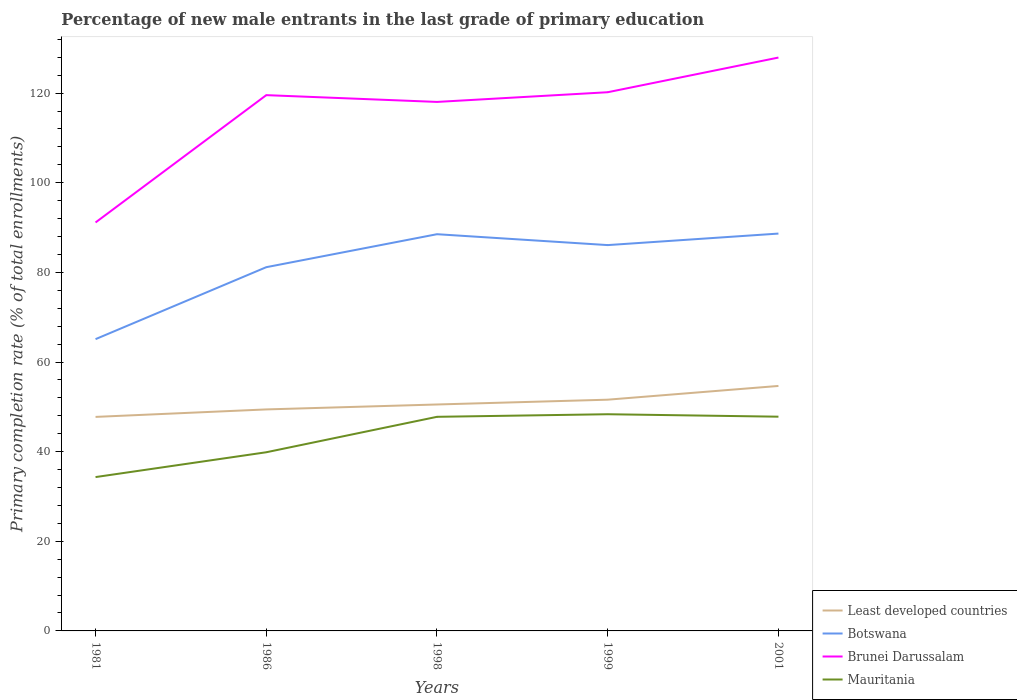Is the number of lines equal to the number of legend labels?
Give a very brief answer. Yes. Across all years, what is the maximum percentage of new male entrants in Least developed countries?
Offer a terse response. 47.75. In which year was the percentage of new male entrants in Botswana maximum?
Keep it short and to the point. 1981. What is the total percentage of new male entrants in Botswana in the graph?
Provide a succinct answer. -4.93. What is the difference between the highest and the second highest percentage of new male entrants in Mauritania?
Offer a very short reply. 14.02. What is the difference between the highest and the lowest percentage of new male entrants in Mauritania?
Give a very brief answer. 3. How many lines are there?
Keep it short and to the point. 4. What is the difference between two consecutive major ticks on the Y-axis?
Give a very brief answer. 20. Are the values on the major ticks of Y-axis written in scientific E-notation?
Give a very brief answer. No. Does the graph contain grids?
Your answer should be compact. No. Where does the legend appear in the graph?
Your response must be concise. Bottom right. How many legend labels are there?
Provide a short and direct response. 4. What is the title of the graph?
Offer a terse response. Percentage of new male entrants in the last grade of primary education. Does "Isle of Man" appear as one of the legend labels in the graph?
Give a very brief answer. No. What is the label or title of the Y-axis?
Provide a succinct answer. Primary completion rate (% of total enrollments). What is the Primary completion rate (% of total enrollments) of Least developed countries in 1981?
Your answer should be compact. 47.75. What is the Primary completion rate (% of total enrollments) in Botswana in 1981?
Keep it short and to the point. 65.1. What is the Primary completion rate (% of total enrollments) of Brunei Darussalam in 1981?
Offer a terse response. 91.14. What is the Primary completion rate (% of total enrollments) of Mauritania in 1981?
Give a very brief answer. 34.33. What is the Primary completion rate (% of total enrollments) in Least developed countries in 1986?
Offer a very short reply. 49.42. What is the Primary completion rate (% of total enrollments) in Botswana in 1986?
Provide a succinct answer. 81.16. What is the Primary completion rate (% of total enrollments) in Brunei Darussalam in 1986?
Make the answer very short. 119.54. What is the Primary completion rate (% of total enrollments) in Mauritania in 1986?
Your answer should be compact. 39.87. What is the Primary completion rate (% of total enrollments) of Least developed countries in 1998?
Offer a terse response. 50.52. What is the Primary completion rate (% of total enrollments) in Botswana in 1998?
Your answer should be very brief. 88.52. What is the Primary completion rate (% of total enrollments) of Brunei Darussalam in 1998?
Give a very brief answer. 118.03. What is the Primary completion rate (% of total enrollments) of Mauritania in 1998?
Your answer should be very brief. 47.77. What is the Primary completion rate (% of total enrollments) of Least developed countries in 1999?
Your response must be concise. 51.6. What is the Primary completion rate (% of total enrollments) in Botswana in 1999?
Give a very brief answer. 86.09. What is the Primary completion rate (% of total enrollments) in Brunei Darussalam in 1999?
Ensure brevity in your answer.  120.2. What is the Primary completion rate (% of total enrollments) of Mauritania in 1999?
Your answer should be very brief. 48.35. What is the Primary completion rate (% of total enrollments) of Least developed countries in 2001?
Give a very brief answer. 54.66. What is the Primary completion rate (% of total enrollments) in Botswana in 2001?
Keep it short and to the point. 88.66. What is the Primary completion rate (% of total enrollments) of Brunei Darussalam in 2001?
Your response must be concise. 127.93. What is the Primary completion rate (% of total enrollments) in Mauritania in 2001?
Your answer should be very brief. 47.8. Across all years, what is the maximum Primary completion rate (% of total enrollments) of Least developed countries?
Ensure brevity in your answer.  54.66. Across all years, what is the maximum Primary completion rate (% of total enrollments) in Botswana?
Offer a very short reply. 88.66. Across all years, what is the maximum Primary completion rate (% of total enrollments) in Brunei Darussalam?
Make the answer very short. 127.93. Across all years, what is the maximum Primary completion rate (% of total enrollments) in Mauritania?
Keep it short and to the point. 48.35. Across all years, what is the minimum Primary completion rate (% of total enrollments) in Least developed countries?
Your answer should be very brief. 47.75. Across all years, what is the minimum Primary completion rate (% of total enrollments) in Botswana?
Your response must be concise. 65.1. Across all years, what is the minimum Primary completion rate (% of total enrollments) in Brunei Darussalam?
Offer a terse response. 91.14. Across all years, what is the minimum Primary completion rate (% of total enrollments) in Mauritania?
Your response must be concise. 34.33. What is the total Primary completion rate (% of total enrollments) of Least developed countries in the graph?
Your response must be concise. 253.96. What is the total Primary completion rate (% of total enrollments) in Botswana in the graph?
Offer a terse response. 409.52. What is the total Primary completion rate (% of total enrollments) in Brunei Darussalam in the graph?
Provide a succinct answer. 576.84. What is the total Primary completion rate (% of total enrollments) of Mauritania in the graph?
Your answer should be compact. 218.11. What is the difference between the Primary completion rate (% of total enrollments) in Least developed countries in 1981 and that in 1986?
Ensure brevity in your answer.  -1.67. What is the difference between the Primary completion rate (% of total enrollments) in Botswana in 1981 and that in 1986?
Keep it short and to the point. -16.06. What is the difference between the Primary completion rate (% of total enrollments) in Brunei Darussalam in 1981 and that in 1986?
Give a very brief answer. -28.41. What is the difference between the Primary completion rate (% of total enrollments) in Mauritania in 1981 and that in 1986?
Offer a very short reply. -5.54. What is the difference between the Primary completion rate (% of total enrollments) of Least developed countries in 1981 and that in 1998?
Provide a succinct answer. -2.77. What is the difference between the Primary completion rate (% of total enrollments) of Botswana in 1981 and that in 1998?
Your response must be concise. -23.41. What is the difference between the Primary completion rate (% of total enrollments) in Brunei Darussalam in 1981 and that in 1998?
Your answer should be compact. -26.9. What is the difference between the Primary completion rate (% of total enrollments) of Mauritania in 1981 and that in 1998?
Offer a very short reply. -13.45. What is the difference between the Primary completion rate (% of total enrollments) in Least developed countries in 1981 and that in 1999?
Give a very brief answer. -3.84. What is the difference between the Primary completion rate (% of total enrollments) of Botswana in 1981 and that in 1999?
Provide a succinct answer. -20.99. What is the difference between the Primary completion rate (% of total enrollments) of Brunei Darussalam in 1981 and that in 1999?
Your response must be concise. -29.06. What is the difference between the Primary completion rate (% of total enrollments) in Mauritania in 1981 and that in 1999?
Offer a very short reply. -14.02. What is the difference between the Primary completion rate (% of total enrollments) in Least developed countries in 1981 and that in 2001?
Give a very brief answer. -6.91. What is the difference between the Primary completion rate (% of total enrollments) in Botswana in 1981 and that in 2001?
Give a very brief answer. -23.55. What is the difference between the Primary completion rate (% of total enrollments) in Brunei Darussalam in 1981 and that in 2001?
Provide a succinct answer. -36.8. What is the difference between the Primary completion rate (% of total enrollments) in Mauritania in 1981 and that in 2001?
Provide a succinct answer. -13.48. What is the difference between the Primary completion rate (% of total enrollments) in Least developed countries in 1986 and that in 1998?
Make the answer very short. -1.1. What is the difference between the Primary completion rate (% of total enrollments) of Botswana in 1986 and that in 1998?
Make the answer very short. -7.36. What is the difference between the Primary completion rate (% of total enrollments) in Brunei Darussalam in 1986 and that in 1998?
Offer a very short reply. 1.51. What is the difference between the Primary completion rate (% of total enrollments) in Mauritania in 1986 and that in 1998?
Provide a short and direct response. -7.91. What is the difference between the Primary completion rate (% of total enrollments) of Least developed countries in 1986 and that in 1999?
Your response must be concise. -2.17. What is the difference between the Primary completion rate (% of total enrollments) of Botswana in 1986 and that in 1999?
Keep it short and to the point. -4.93. What is the difference between the Primary completion rate (% of total enrollments) of Brunei Darussalam in 1986 and that in 1999?
Provide a succinct answer. -0.65. What is the difference between the Primary completion rate (% of total enrollments) in Mauritania in 1986 and that in 1999?
Keep it short and to the point. -8.48. What is the difference between the Primary completion rate (% of total enrollments) in Least developed countries in 1986 and that in 2001?
Your response must be concise. -5.24. What is the difference between the Primary completion rate (% of total enrollments) in Botswana in 1986 and that in 2001?
Offer a very short reply. -7.5. What is the difference between the Primary completion rate (% of total enrollments) of Brunei Darussalam in 1986 and that in 2001?
Keep it short and to the point. -8.39. What is the difference between the Primary completion rate (% of total enrollments) of Mauritania in 1986 and that in 2001?
Your response must be concise. -7.94. What is the difference between the Primary completion rate (% of total enrollments) of Least developed countries in 1998 and that in 1999?
Offer a terse response. -1.07. What is the difference between the Primary completion rate (% of total enrollments) in Botswana in 1998 and that in 1999?
Give a very brief answer. 2.43. What is the difference between the Primary completion rate (% of total enrollments) of Brunei Darussalam in 1998 and that in 1999?
Your answer should be compact. -2.16. What is the difference between the Primary completion rate (% of total enrollments) in Mauritania in 1998 and that in 1999?
Your answer should be compact. -0.58. What is the difference between the Primary completion rate (% of total enrollments) in Least developed countries in 1998 and that in 2001?
Provide a succinct answer. -4.14. What is the difference between the Primary completion rate (% of total enrollments) in Botswana in 1998 and that in 2001?
Offer a terse response. -0.14. What is the difference between the Primary completion rate (% of total enrollments) in Brunei Darussalam in 1998 and that in 2001?
Your answer should be very brief. -9.9. What is the difference between the Primary completion rate (% of total enrollments) of Mauritania in 1998 and that in 2001?
Keep it short and to the point. -0.03. What is the difference between the Primary completion rate (% of total enrollments) in Least developed countries in 1999 and that in 2001?
Your response must be concise. -3.07. What is the difference between the Primary completion rate (% of total enrollments) of Botswana in 1999 and that in 2001?
Offer a terse response. -2.57. What is the difference between the Primary completion rate (% of total enrollments) of Brunei Darussalam in 1999 and that in 2001?
Provide a short and direct response. -7.74. What is the difference between the Primary completion rate (% of total enrollments) of Mauritania in 1999 and that in 2001?
Keep it short and to the point. 0.55. What is the difference between the Primary completion rate (% of total enrollments) in Least developed countries in 1981 and the Primary completion rate (% of total enrollments) in Botswana in 1986?
Offer a very short reply. -33.4. What is the difference between the Primary completion rate (% of total enrollments) in Least developed countries in 1981 and the Primary completion rate (% of total enrollments) in Brunei Darussalam in 1986?
Keep it short and to the point. -71.79. What is the difference between the Primary completion rate (% of total enrollments) in Least developed countries in 1981 and the Primary completion rate (% of total enrollments) in Mauritania in 1986?
Give a very brief answer. 7.89. What is the difference between the Primary completion rate (% of total enrollments) in Botswana in 1981 and the Primary completion rate (% of total enrollments) in Brunei Darussalam in 1986?
Give a very brief answer. -54.44. What is the difference between the Primary completion rate (% of total enrollments) of Botswana in 1981 and the Primary completion rate (% of total enrollments) of Mauritania in 1986?
Provide a succinct answer. 25.24. What is the difference between the Primary completion rate (% of total enrollments) in Brunei Darussalam in 1981 and the Primary completion rate (% of total enrollments) in Mauritania in 1986?
Your answer should be compact. 51.27. What is the difference between the Primary completion rate (% of total enrollments) in Least developed countries in 1981 and the Primary completion rate (% of total enrollments) in Botswana in 1998?
Offer a terse response. -40.76. What is the difference between the Primary completion rate (% of total enrollments) of Least developed countries in 1981 and the Primary completion rate (% of total enrollments) of Brunei Darussalam in 1998?
Your answer should be very brief. -70.28. What is the difference between the Primary completion rate (% of total enrollments) of Least developed countries in 1981 and the Primary completion rate (% of total enrollments) of Mauritania in 1998?
Offer a terse response. -0.02. What is the difference between the Primary completion rate (% of total enrollments) of Botswana in 1981 and the Primary completion rate (% of total enrollments) of Brunei Darussalam in 1998?
Make the answer very short. -52.93. What is the difference between the Primary completion rate (% of total enrollments) in Botswana in 1981 and the Primary completion rate (% of total enrollments) in Mauritania in 1998?
Keep it short and to the point. 17.33. What is the difference between the Primary completion rate (% of total enrollments) of Brunei Darussalam in 1981 and the Primary completion rate (% of total enrollments) of Mauritania in 1998?
Keep it short and to the point. 43.36. What is the difference between the Primary completion rate (% of total enrollments) of Least developed countries in 1981 and the Primary completion rate (% of total enrollments) of Botswana in 1999?
Give a very brief answer. -38.33. What is the difference between the Primary completion rate (% of total enrollments) of Least developed countries in 1981 and the Primary completion rate (% of total enrollments) of Brunei Darussalam in 1999?
Your response must be concise. -72.44. What is the difference between the Primary completion rate (% of total enrollments) in Least developed countries in 1981 and the Primary completion rate (% of total enrollments) in Mauritania in 1999?
Provide a short and direct response. -0.59. What is the difference between the Primary completion rate (% of total enrollments) in Botswana in 1981 and the Primary completion rate (% of total enrollments) in Brunei Darussalam in 1999?
Your response must be concise. -55.09. What is the difference between the Primary completion rate (% of total enrollments) in Botswana in 1981 and the Primary completion rate (% of total enrollments) in Mauritania in 1999?
Your answer should be compact. 16.76. What is the difference between the Primary completion rate (% of total enrollments) in Brunei Darussalam in 1981 and the Primary completion rate (% of total enrollments) in Mauritania in 1999?
Offer a very short reply. 42.79. What is the difference between the Primary completion rate (% of total enrollments) in Least developed countries in 1981 and the Primary completion rate (% of total enrollments) in Botswana in 2001?
Provide a short and direct response. -40.9. What is the difference between the Primary completion rate (% of total enrollments) of Least developed countries in 1981 and the Primary completion rate (% of total enrollments) of Brunei Darussalam in 2001?
Offer a very short reply. -80.18. What is the difference between the Primary completion rate (% of total enrollments) of Least developed countries in 1981 and the Primary completion rate (% of total enrollments) of Mauritania in 2001?
Make the answer very short. -0.05. What is the difference between the Primary completion rate (% of total enrollments) of Botswana in 1981 and the Primary completion rate (% of total enrollments) of Brunei Darussalam in 2001?
Offer a very short reply. -62.83. What is the difference between the Primary completion rate (% of total enrollments) of Botswana in 1981 and the Primary completion rate (% of total enrollments) of Mauritania in 2001?
Offer a terse response. 17.3. What is the difference between the Primary completion rate (% of total enrollments) in Brunei Darussalam in 1981 and the Primary completion rate (% of total enrollments) in Mauritania in 2001?
Provide a succinct answer. 43.33. What is the difference between the Primary completion rate (% of total enrollments) in Least developed countries in 1986 and the Primary completion rate (% of total enrollments) in Botswana in 1998?
Ensure brevity in your answer.  -39.09. What is the difference between the Primary completion rate (% of total enrollments) of Least developed countries in 1986 and the Primary completion rate (% of total enrollments) of Brunei Darussalam in 1998?
Offer a very short reply. -68.61. What is the difference between the Primary completion rate (% of total enrollments) of Least developed countries in 1986 and the Primary completion rate (% of total enrollments) of Mauritania in 1998?
Ensure brevity in your answer.  1.65. What is the difference between the Primary completion rate (% of total enrollments) in Botswana in 1986 and the Primary completion rate (% of total enrollments) in Brunei Darussalam in 1998?
Offer a terse response. -36.87. What is the difference between the Primary completion rate (% of total enrollments) in Botswana in 1986 and the Primary completion rate (% of total enrollments) in Mauritania in 1998?
Keep it short and to the point. 33.39. What is the difference between the Primary completion rate (% of total enrollments) in Brunei Darussalam in 1986 and the Primary completion rate (% of total enrollments) in Mauritania in 1998?
Provide a succinct answer. 71.77. What is the difference between the Primary completion rate (% of total enrollments) of Least developed countries in 1986 and the Primary completion rate (% of total enrollments) of Botswana in 1999?
Keep it short and to the point. -36.67. What is the difference between the Primary completion rate (% of total enrollments) in Least developed countries in 1986 and the Primary completion rate (% of total enrollments) in Brunei Darussalam in 1999?
Provide a succinct answer. -70.77. What is the difference between the Primary completion rate (% of total enrollments) in Least developed countries in 1986 and the Primary completion rate (% of total enrollments) in Mauritania in 1999?
Offer a terse response. 1.07. What is the difference between the Primary completion rate (% of total enrollments) in Botswana in 1986 and the Primary completion rate (% of total enrollments) in Brunei Darussalam in 1999?
Your answer should be compact. -39.04. What is the difference between the Primary completion rate (% of total enrollments) of Botswana in 1986 and the Primary completion rate (% of total enrollments) of Mauritania in 1999?
Offer a very short reply. 32.81. What is the difference between the Primary completion rate (% of total enrollments) in Brunei Darussalam in 1986 and the Primary completion rate (% of total enrollments) in Mauritania in 1999?
Your response must be concise. 71.2. What is the difference between the Primary completion rate (% of total enrollments) of Least developed countries in 1986 and the Primary completion rate (% of total enrollments) of Botswana in 2001?
Give a very brief answer. -39.24. What is the difference between the Primary completion rate (% of total enrollments) in Least developed countries in 1986 and the Primary completion rate (% of total enrollments) in Brunei Darussalam in 2001?
Keep it short and to the point. -78.51. What is the difference between the Primary completion rate (% of total enrollments) of Least developed countries in 1986 and the Primary completion rate (% of total enrollments) of Mauritania in 2001?
Make the answer very short. 1.62. What is the difference between the Primary completion rate (% of total enrollments) in Botswana in 1986 and the Primary completion rate (% of total enrollments) in Brunei Darussalam in 2001?
Provide a succinct answer. -46.77. What is the difference between the Primary completion rate (% of total enrollments) of Botswana in 1986 and the Primary completion rate (% of total enrollments) of Mauritania in 2001?
Provide a succinct answer. 33.36. What is the difference between the Primary completion rate (% of total enrollments) of Brunei Darussalam in 1986 and the Primary completion rate (% of total enrollments) of Mauritania in 2001?
Give a very brief answer. 71.74. What is the difference between the Primary completion rate (% of total enrollments) in Least developed countries in 1998 and the Primary completion rate (% of total enrollments) in Botswana in 1999?
Make the answer very short. -35.56. What is the difference between the Primary completion rate (% of total enrollments) of Least developed countries in 1998 and the Primary completion rate (% of total enrollments) of Brunei Darussalam in 1999?
Provide a short and direct response. -69.67. What is the difference between the Primary completion rate (% of total enrollments) in Least developed countries in 1998 and the Primary completion rate (% of total enrollments) in Mauritania in 1999?
Your response must be concise. 2.18. What is the difference between the Primary completion rate (% of total enrollments) of Botswana in 1998 and the Primary completion rate (% of total enrollments) of Brunei Darussalam in 1999?
Make the answer very short. -31.68. What is the difference between the Primary completion rate (% of total enrollments) of Botswana in 1998 and the Primary completion rate (% of total enrollments) of Mauritania in 1999?
Your response must be concise. 40.17. What is the difference between the Primary completion rate (% of total enrollments) of Brunei Darussalam in 1998 and the Primary completion rate (% of total enrollments) of Mauritania in 1999?
Your answer should be very brief. 69.69. What is the difference between the Primary completion rate (% of total enrollments) of Least developed countries in 1998 and the Primary completion rate (% of total enrollments) of Botswana in 2001?
Your response must be concise. -38.13. What is the difference between the Primary completion rate (% of total enrollments) in Least developed countries in 1998 and the Primary completion rate (% of total enrollments) in Brunei Darussalam in 2001?
Offer a very short reply. -77.41. What is the difference between the Primary completion rate (% of total enrollments) in Least developed countries in 1998 and the Primary completion rate (% of total enrollments) in Mauritania in 2001?
Your answer should be very brief. 2.72. What is the difference between the Primary completion rate (% of total enrollments) of Botswana in 1998 and the Primary completion rate (% of total enrollments) of Brunei Darussalam in 2001?
Give a very brief answer. -39.42. What is the difference between the Primary completion rate (% of total enrollments) of Botswana in 1998 and the Primary completion rate (% of total enrollments) of Mauritania in 2001?
Provide a succinct answer. 40.71. What is the difference between the Primary completion rate (% of total enrollments) of Brunei Darussalam in 1998 and the Primary completion rate (% of total enrollments) of Mauritania in 2001?
Ensure brevity in your answer.  70.23. What is the difference between the Primary completion rate (% of total enrollments) in Least developed countries in 1999 and the Primary completion rate (% of total enrollments) in Botswana in 2001?
Your response must be concise. -37.06. What is the difference between the Primary completion rate (% of total enrollments) in Least developed countries in 1999 and the Primary completion rate (% of total enrollments) in Brunei Darussalam in 2001?
Offer a very short reply. -76.34. What is the difference between the Primary completion rate (% of total enrollments) in Least developed countries in 1999 and the Primary completion rate (% of total enrollments) in Mauritania in 2001?
Your answer should be very brief. 3.79. What is the difference between the Primary completion rate (% of total enrollments) in Botswana in 1999 and the Primary completion rate (% of total enrollments) in Brunei Darussalam in 2001?
Provide a succinct answer. -41.84. What is the difference between the Primary completion rate (% of total enrollments) of Botswana in 1999 and the Primary completion rate (% of total enrollments) of Mauritania in 2001?
Provide a short and direct response. 38.29. What is the difference between the Primary completion rate (% of total enrollments) in Brunei Darussalam in 1999 and the Primary completion rate (% of total enrollments) in Mauritania in 2001?
Keep it short and to the point. 72.39. What is the average Primary completion rate (% of total enrollments) of Least developed countries per year?
Your answer should be compact. 50.79. What is the average Primary completion rate (% of total enrollments) in Botswana per year?
Your response must be concise. 81.9. What is the average Primary completion rate (% of total enrollments) of Brunei Darussalam per year?
Offer a very short reply. 115.37. What is the average Primary completion rate (% of total enrollments) of Mauritania per year?
Provide a succinct answer. 43.62. In the year 1981, what is the difference between the Primary completion rate (% of total enrollments) of Least developed countries and Primary completion rate (% of total enrollments) of Botswana?
Your answer should be very brief. -17.35. In the year 1981, what is the difference between the Primary completion rate (% of total enrollments) in Least developed countries and Primary completion rate (% of total enrollments) in Brunei Darussalam?
Provide a succinct answer. -43.38. In the year 1981, what is the difference between the Primary completion rate (% of total enrollments) of Least developed countries and Primary completion rate (% of total enrollments) of Mauritania?
Keep it short and to the point. 13.43. In the year 1981, what is the difference between the Primary completion rate (% of total enrollments) in Botswana and Primary completion rate (% of total enrollments) in Brunei Darussalam?
Offer a terse response. -26.03. In the year 1981, what is the difference between the Primary completion rate (% of total enrollments) of Botswana and Primary completion rate (% of total enrollments) of Mauritania?
Ensure brevity in your answer.  30.78. In the year 1981, what is the difference between the Primary completion rate (% of total enrollments) in Brunei Darussalam and Primary completion rate (% of total enrollments) in Mauritania?
Your answer should be very brief. 56.81. In the year 1986, what is the difference between the Primary completion rate (% of total enrollments) in Least developed countries and Primary completion rate (% of total enrollments) in Botswana?
Make the answer very short. -31.74. In the year 1986, what is the difference between the Primary completion rate (% of total enrollments) of Least developed countries and Primary completion rate (% of total enrollments) of Brunei Darussalam?
Your answer should be compact. -70.12. In the year 1986, what is the difference between the Primary completion rate (% of total enrollments) in Least developed countries and Primary completion rate (% of total enrollments) in Mauritania?
Your answer should be very brief. 9.56. In the year 1986, what is the difference between the Primary completion rate (% of total enrollments) in Botswana and Primary completion rate (% of total enrollments) in Brunei Darussalam?
Your answer should be compact. -38.39. In the year 1986, what is the difference between the Primary completion rate (% of total enrollments) of Botswana and Primary completion rate (% of total enrollments) of Mauritania?
Provide a short and direct response. 41.29. In the year 1986, what is the difference between the Primary completion rate (% of total enrollments) of Brunei Darussalam and Primary completion rate (% of total enrollments) of Mauritania?
Offer a terse response. 79.68. In the year 1998, what is the difference between the Primary completion rate (% of total enrollments) of Least developed countries and Primary completion rate (% of total enrollments) of Botswana?
Provide a short and direct response. -37.99. In the year 1998, what is the difference between the Primary completion rate (% of total enrollments) of Least developed countries and Primary completion rate (% of total enrollments) of Brunei Darussalam?
Keep it short and to the point. -67.51. In the year 1998, what is the difference between the Primary completion rate (% of total enrollments) of Least developed countries and Primary completion rate (% of total enrollments) of Mauritania?
Your response must be concise. 2.75. In the year 1998, what is the difference between the Primary completion rate (% of total enrollments) in Botswana and Primary completion rate (% of total enrollments) in Brunei Darussalam?
Provide a short and direct response. -29.52. In the year 1998, what is the difference between the Primary completion rate (% of total enrollments) in Botswana and Primary completion rate (% of total enrollments) in Mauritania?
Offer a terse response. 40.74. In the year 1998, what is the difference between the Primary completion rate (% of total enrollments) in Brunei Darussalam and Primary completion rate (% of total enrollments) in Mauritania?
Your answer should be very brief. 70.26. In the year 1999, what is the difference between the Primary completion rate (% of total enrollments) in Least developed countries and Primary completion rate (% of total enrollments) in Botswana?
Your answer should be very brief. -34.49. In the year 1999, what is the difference between the Primary completion rate (% of total enrollments) in Least developed countries and Primary completion rate (% of total enrollments) in Brunei Darussalam?
Provide a succinct answer. -68.6. In the year 1999, what is the difference between the Primary completion rate (% of total enrollments) in Least developed countries and Primary completion rate (% of total enrollments) in Mauritania?
Ensure brevity in your answer.  3.25. In the year 1999, what is the difference between the Primary completion rate (% of total enrollments) of Botswana and Primary completion rate (% of total enrollments) of Brunei Darussalam?
Give a very brief answer. -34.11. In the year 1999, what is the difference between the Primary completion rate (% of total enrollments) in Botswana and Primary completion rate (% of total enrollments) in Mauritania?
Offer a very short reply. 37.74. In the year 1999, what is the difference between the Primary completion rate (% of total enrollments) in Brunei Darussalam and Primary completion rate (% of total enrollments) in Mauritania?
Make the answer very short. 71.85. In the year 2001, what is the difference between the Primary completion rate (% of total enrollments) in Least developed countries and Primary completion rate (% of total enrollments) in Botswana?
Your answer should be compact. -34. In the year 2001, what is the difference between the Primary completion rate (% of total enrollments) of Least developed countries and Primary completion rate (% of total enrollments) of Brunei Darussalam?
Give a very brief answer. -73.27. In the year 2001, what is the difference between the Primary completion rate (% of total enrollments) of Least developed countries and Primary completion rate (% of total enrollments) of Mauritania?
Ensure brevity in your answer.  6.86. In the year 2001, what is the difference between the Primary completion rate (% of total enrollments) of Botswana and Primary completion rate (% of total enrollments) of Brunei Darussalam?
Offer a terse response. -39.28. In the year 2001, what is the difference between the Primary completion rate (% of total enrollments) in Botswana and Primary completion rate (% of total enrollments) in Mauritania?
Give a very brief answer. 40.86. In the year 2001, what is the difference between the Primary completion rate (% of total enrollments) of Brunei Darussalam and Primary completion rate (% of total enrollments) of Mauritania?
Keep it short and to the point. 80.13. What is the ratio of the Primary completion rate (% of total enrollments) in Least developed countries in 1981 to that in 1986?
Make the answer very short. 0.97. What is the ratio of the Primary completion rate (% of total enrollments) in Botswana in 1981 to that in 1986?
Your response must be concise. 0.8. What is the ratio of the Primary completion rate (% of total enrollments) in Brunei Darussalam in 1981 to that in 1986?
Provide a succinct answer. 0.76. What is the ratio of the Primary completion rate (% of total enrollments) of Mauritania in 1981 to that in 1986?
Provide a short and direct response. 0.86. What is the ratio of the Primary completion rate (% of total enrollments) of Least developed countries in 1981 to that in 1998?
Make the answer very short. 0.95. What is the ratio of the Primary completion rate (% of total enrollments) in Botswana in 1981 to that in 1998?
Offer a terse response. 0.74. What is the ratio of the Primary completion rate (% of total enrollments) in Brunei Darussalam in 1981 to that in 1998?
Ensure brevity in your answer.  0.77. What is the ratio of the Primary completion rate (% of total enrollments) of Mauritania in 1981 to that in 1998?
Provide a short and direct response. 0.72. What is the ratio of the Primary completion rate (% of total enrollments) in Least developed countries in 1981 to that in 1999?
Your answer should be very brief. 0.93. What is the ratio of the Primary completion rate (% of total enrollments) in Botswana in 1981 to that in 1999?
Provide a succinct answer. 0.76. What is the ratio of the Primary completion rate (% of total enrollments) in Brunei Darussalam in 1981 to that in 1999?
Your answer should be very brief. 0.76. What is the ratio of the Primary completion rate (% of total enrollments) in Mauritania in 1981 to that in 1999?
Your answer should be compact. 0.71. What is the ratio of the Primary completion rate (% of total enrollments) of Least developed countries in 1981 to that in 2001?
Make the answer very short. 0.87. What is the ratio of the Primary completion rate (% of total enrollments) of Botswana in 1981 to that in 2001?
Provide a short and direct response. 0.73. What is the ratio of the Primary completion rate (% of total enrollments) in Brunei Darussalam in 1981 to that in 2001?
Offer a terse response. 0.71. What is the ratio of the Primary completion rate (% of total enrollments) in Mauritania in 1981 to that in 2001?
Your answer should be compact. 0.72. What is the ratio of the Primary completion rate (% of total enrollments) of Least developed countries in 1986 to that in 1998?
Ensure brevity in your answer.  0.98. What is the ratio of the Primary completion rate (% of total enrollments) of Botswana in 1986 to that in 1998?
Keep it short and to the point. 0.92. What is the ratio of the Primary completion rate (% of total enrollments) of Brunei Darussalam in 1986 to that in 1998?
Your answer should be compact. 1.01. What is the ratio of the Primary completion rate (% of total enrollments) in Mauritania in 1986 to that in 1998?
Your answer should be very brief. 0.83. What is the ratio of the Primary completion rate (% of total enrollments) of Least developed countries in 1986 to that in 1999?
Ensure brevity in your answer.  0.96. What is the ratio of the Primary completion rate (% of total enrollments) of Botswana in 1986 to that in 1999?
Give a very brief answer. 0.94. What is the ratio of the Primary completion rate (% of total enrollments) in Mauritania in 1986 to that in 1999?
Offer a very short reply. 0.82. What is the ratio of the Primary completion rate (% of total enrollments) of Least developed countries in 1986 to that in 2001?
Give a very brief answer. 0.9. What is the ratio of the Primary completion rate (% of total enrollments) of Botswana in 1986 to that in 2001?
Your answer should be compact. 0.92. What is the ratio of the Primary completion rate (% of total enrollments) in Brunei Darussalam in 1986 to that in 2001?
Your answer should be very brief. 0.93. What is the ratio of the Primary completion rate (% of total enrollments) in Mauritania in 1986 to that in 2001?
Ensure brevity in your answer.  0.83. What is the ratio of the Primary completion rate (% of total enrollments) in Least developed countries in 1998 to that in 1999?
Make the answer very short. 0.98. What is the ratio of the Primary completion rate (% of total enrollments) in Botswana in 1998 to that in 1999?
Provide a short and direct response. 1.03. What is the ratio of the Primary completion rate (% of total enrollments) in Least developed countries in 1998 to that in 2001?
Your answer should be compact. 0.92. What is the ratio of the Primary completion rate (% of total enrollments) of Brunei Darussalam in 1998 to that in 2001?
Your answer should be compact. 0.92. What is the ratio of the Primary completion rate (% of total enrollments) of Mauritania in 1998 to that in 2001?
Provide a succinct answer. 1. What is the ratio of the Primary completion rate (% of total enrollments) in Least developed countries in 1999 to that in 2001?
Give a very brief answer. 0.94. What is the ratio of the Primary completion rate (% of total enrollments) of Botswana in 1999 to that in 2001?
Offer a very short reply. 0.97. What is the ratio of the Primary completion rate (% of total enrollments) in Brunei Darussalam in 1999 to that in 2001?
Your answer should be compact. 0.94. What is the ratio of the Primary completion rate (% of total enrollments) of Mauritania in 1999 to that in 2001?
Offer a very short reply. 1.01. What is the difference between the highest and the second highest Primary completion rate (% of total enrollments) in Least developed countries?
Provide a short and direct response. 3.07. What is the difference between the highest and the second highest Primary completion rate (% of total enrollments) in Botswana?
Your answer should be very brief. 0.14. What is the difference between the highest and the second highest Primary completion rate (% of total enrollments) of Brunei Darussalam?
Provide a succinct answer. 7.74. What is the difference between the highest and the second highest Primary completion rate (% of total enrollments) of Mauritania?
Provide a short and direct response. 0.55. What is the difference between the highest and the lowest Primary completion rate (% of total enrollments) of Least developed countries?
Your answer should be very brief. 6.91. What is the difference between the highest and the lowest Primary completion rate (% of total enrollments) of Botswana?
Ensure brevity in your answer.  23.55. What is the difference between the highest and the lowest Primary completion rate (% of total enrollments) of Brunei Darussalam?
Your response must be concise. 36.8. What is the difference between the highest and the lowest Primary completion rate (% of total enrollments) in Mauritania?
Provide a succinct answer. 14.02. 